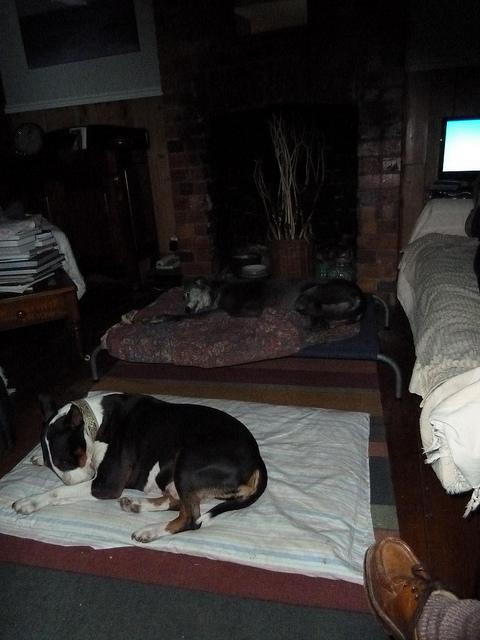What can be built along the back wall? fire 